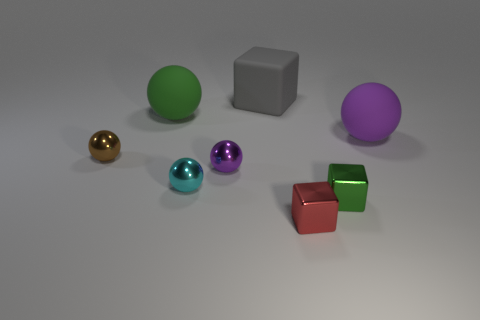Subtract all green spheres. How many spheres are left? 4 Subtract all blue spheres. Subtract all cyan cylinders. How many spheres are left? 5 Add 1 small things. How many objects exist? 9 Subtract all balls. How many objects are left? 3 Add 6 tiny brown metal objects. How many tiny brown metal objects are left? 7 Add 5 green matte balls. How many green matte balls exist? 6 Subtract 1 brown balls. How many objects are left? 7 Subtract all tiny red cubes. Subtract all cyan metal spheres. How many objects are left? 6 